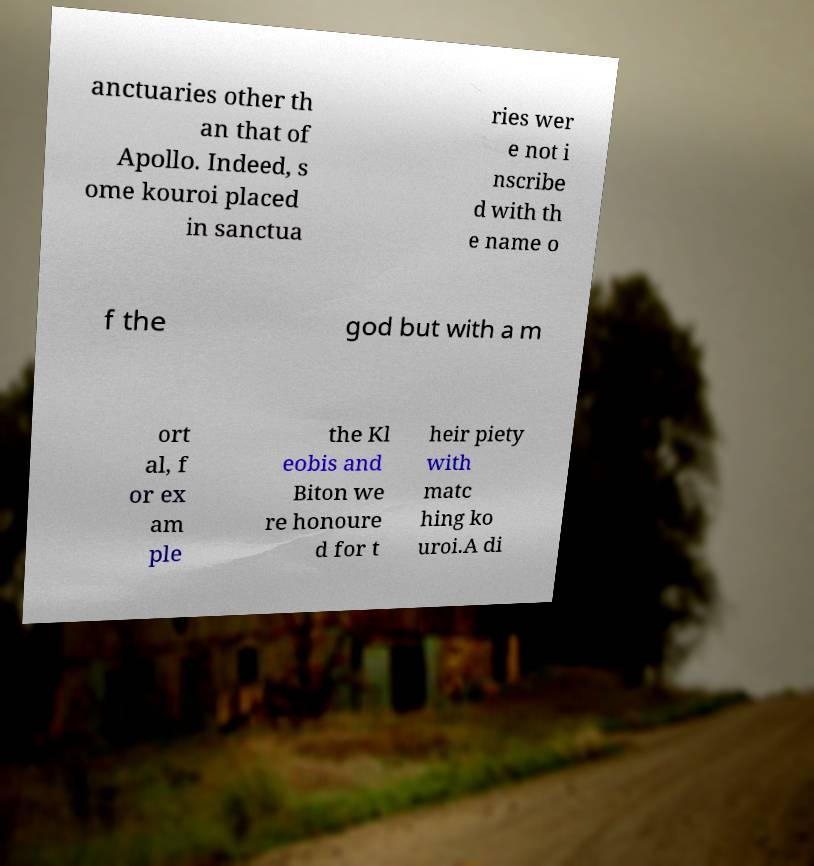Can you accurately transcribe the text from the provided image for me? anctuaries other th an that of Apollo. Indeed, s ome kouroi placed in sanctua ries wer e not i nscribe d with th e name o f the god but with a m ort al, f or ex am ple the Kl eobis and Biton we re honoure d for t heir piety with matc hing ko uroi.A di 